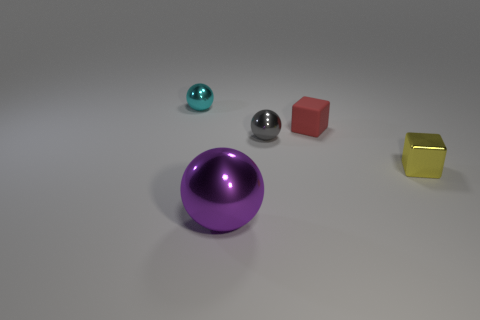Are there any other things that are the same size as the purple ball?
Provide a short and direct response. No. Is the tiny ball to the right of the cyan metallic object made of the same material as the tiny thing to the left of the big purple thing?
Make the answer very short. Yes. How big is the metal ball on the right side of the purple object on the left side of the tiny metal sphere to the right of the small cyan shiny thing?
Ensure brevity in your answer.  Small. What number of gray spheres have the same material as the tiny red object?
Give a very brief answer. 0. Is the number of small blue metal objects less than the number of yellow metal cubes?
Provide a short and direct response. Yes. There is a yellow shiny object that is the same shape as the red rubber thing; what size is it?
Provide a succinct answer. Small. Are the cube that is in front of the gray ball and the purple ball made of the same material?
Your answer should be compact. Yes. Is the yellow object the same shape as the matte thing?
Offer a terse response. Yes. How many objects are either tiny balls that are to the right of the large purple sphere or cyan balls?
Make the answer very short. 2. The purple object that is the same material as the small cyan thing is what size?
Make the answer very short. Large. 